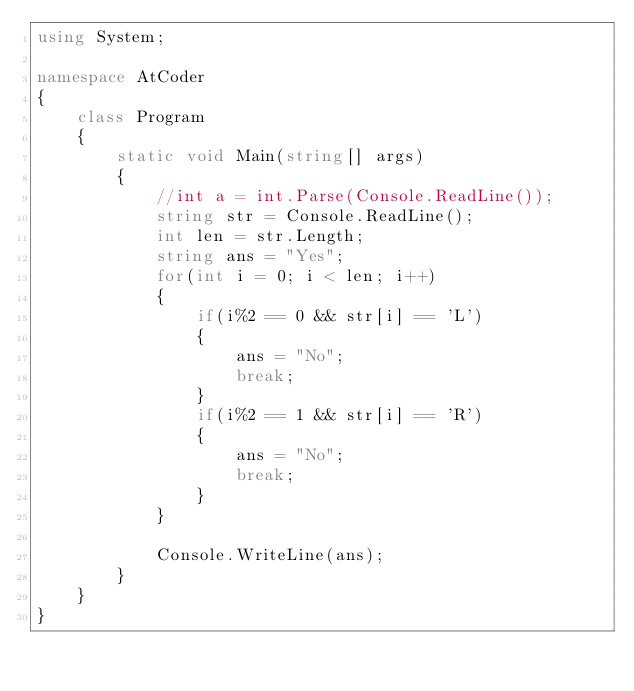<code> <loc_0><loc_0><loc_500><loc_500><_C#_>using System;

namespace AtCoder
{
    class Program
    {
        static void Main(string[] args)
        {
            //int a = int.Parse(Console.ReadLine());
            string str = Console.ReadLine();
            int len = str.Length;
            string ans = "Yes";
            for(int i = 0; i < len; i++)
            {
                if(i%2 == 0 && str[i] == 'L')
                {
                    ans = "No";
                    break;
                }
                if(i%2 == 1 && str[i] == 'R')
                {
                    ans = "No";
                    break;
                }
            }
            
            Console.WriteLine(ans);
        }
    }
}

</code> 